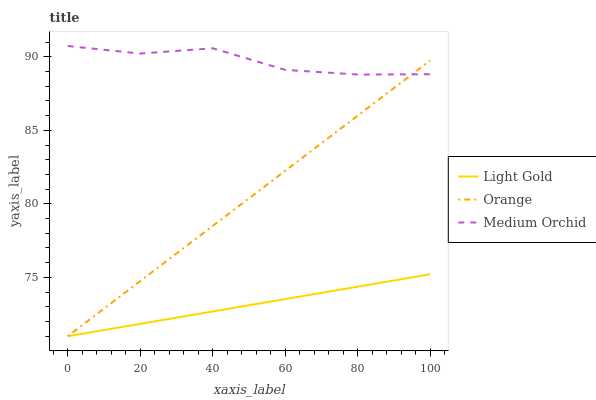Does Light Gold have the minimum area under the curve?
Answer yes or no. Yes. Does Medium Orchid have the maximum area under the curve?
Answer yes or no. Yes. Does Medium Orchid have the minimum area under the curve?
Answer yes or no. No. Does Light Gold have the maximum area under the curve?
Answer yes or no. No. Is Light Gold the smoothest?
Answer yes or no. Yes. Is Medium Orchid the roughest?
Answer yes or no. Yes. Is Medium Orchid the smoothest?
Answer yes or no. No. Is Light Gold the roughest?
Answer yes or no. No. Does Orange have the lowest value?
Answer yes or no. Yes. Does Medium Orchid have the lowest value?
Answer yes or no. No. Does Medium Orchid have the highest value?
Answer yes or no. Yes. Does Light Gold have the highest value?
Answer yes or no. No. Is Light Gold less than Medium Orchid?
Answer yes or no. Yes. Is Medium Orchid greater than Light Gold?
Answer yes or no. Yes. Does Orange intersect Light Gold?
Answer yes or no. Yes. Is Orange less than Light Gold?
Answer yes or no. No. Is Orange greater than Light Gold?
Answer yes or no. No. Does Light Gold intersect Medium Orchid?
Answer yes or no. No. 